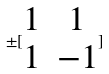<formula> <loc_0><loc_0><loc_500><loc_500>\pm [ \begin{matrix} 1 & 1 \\ 1 & - 1 \end{matrix} ]</formula> 